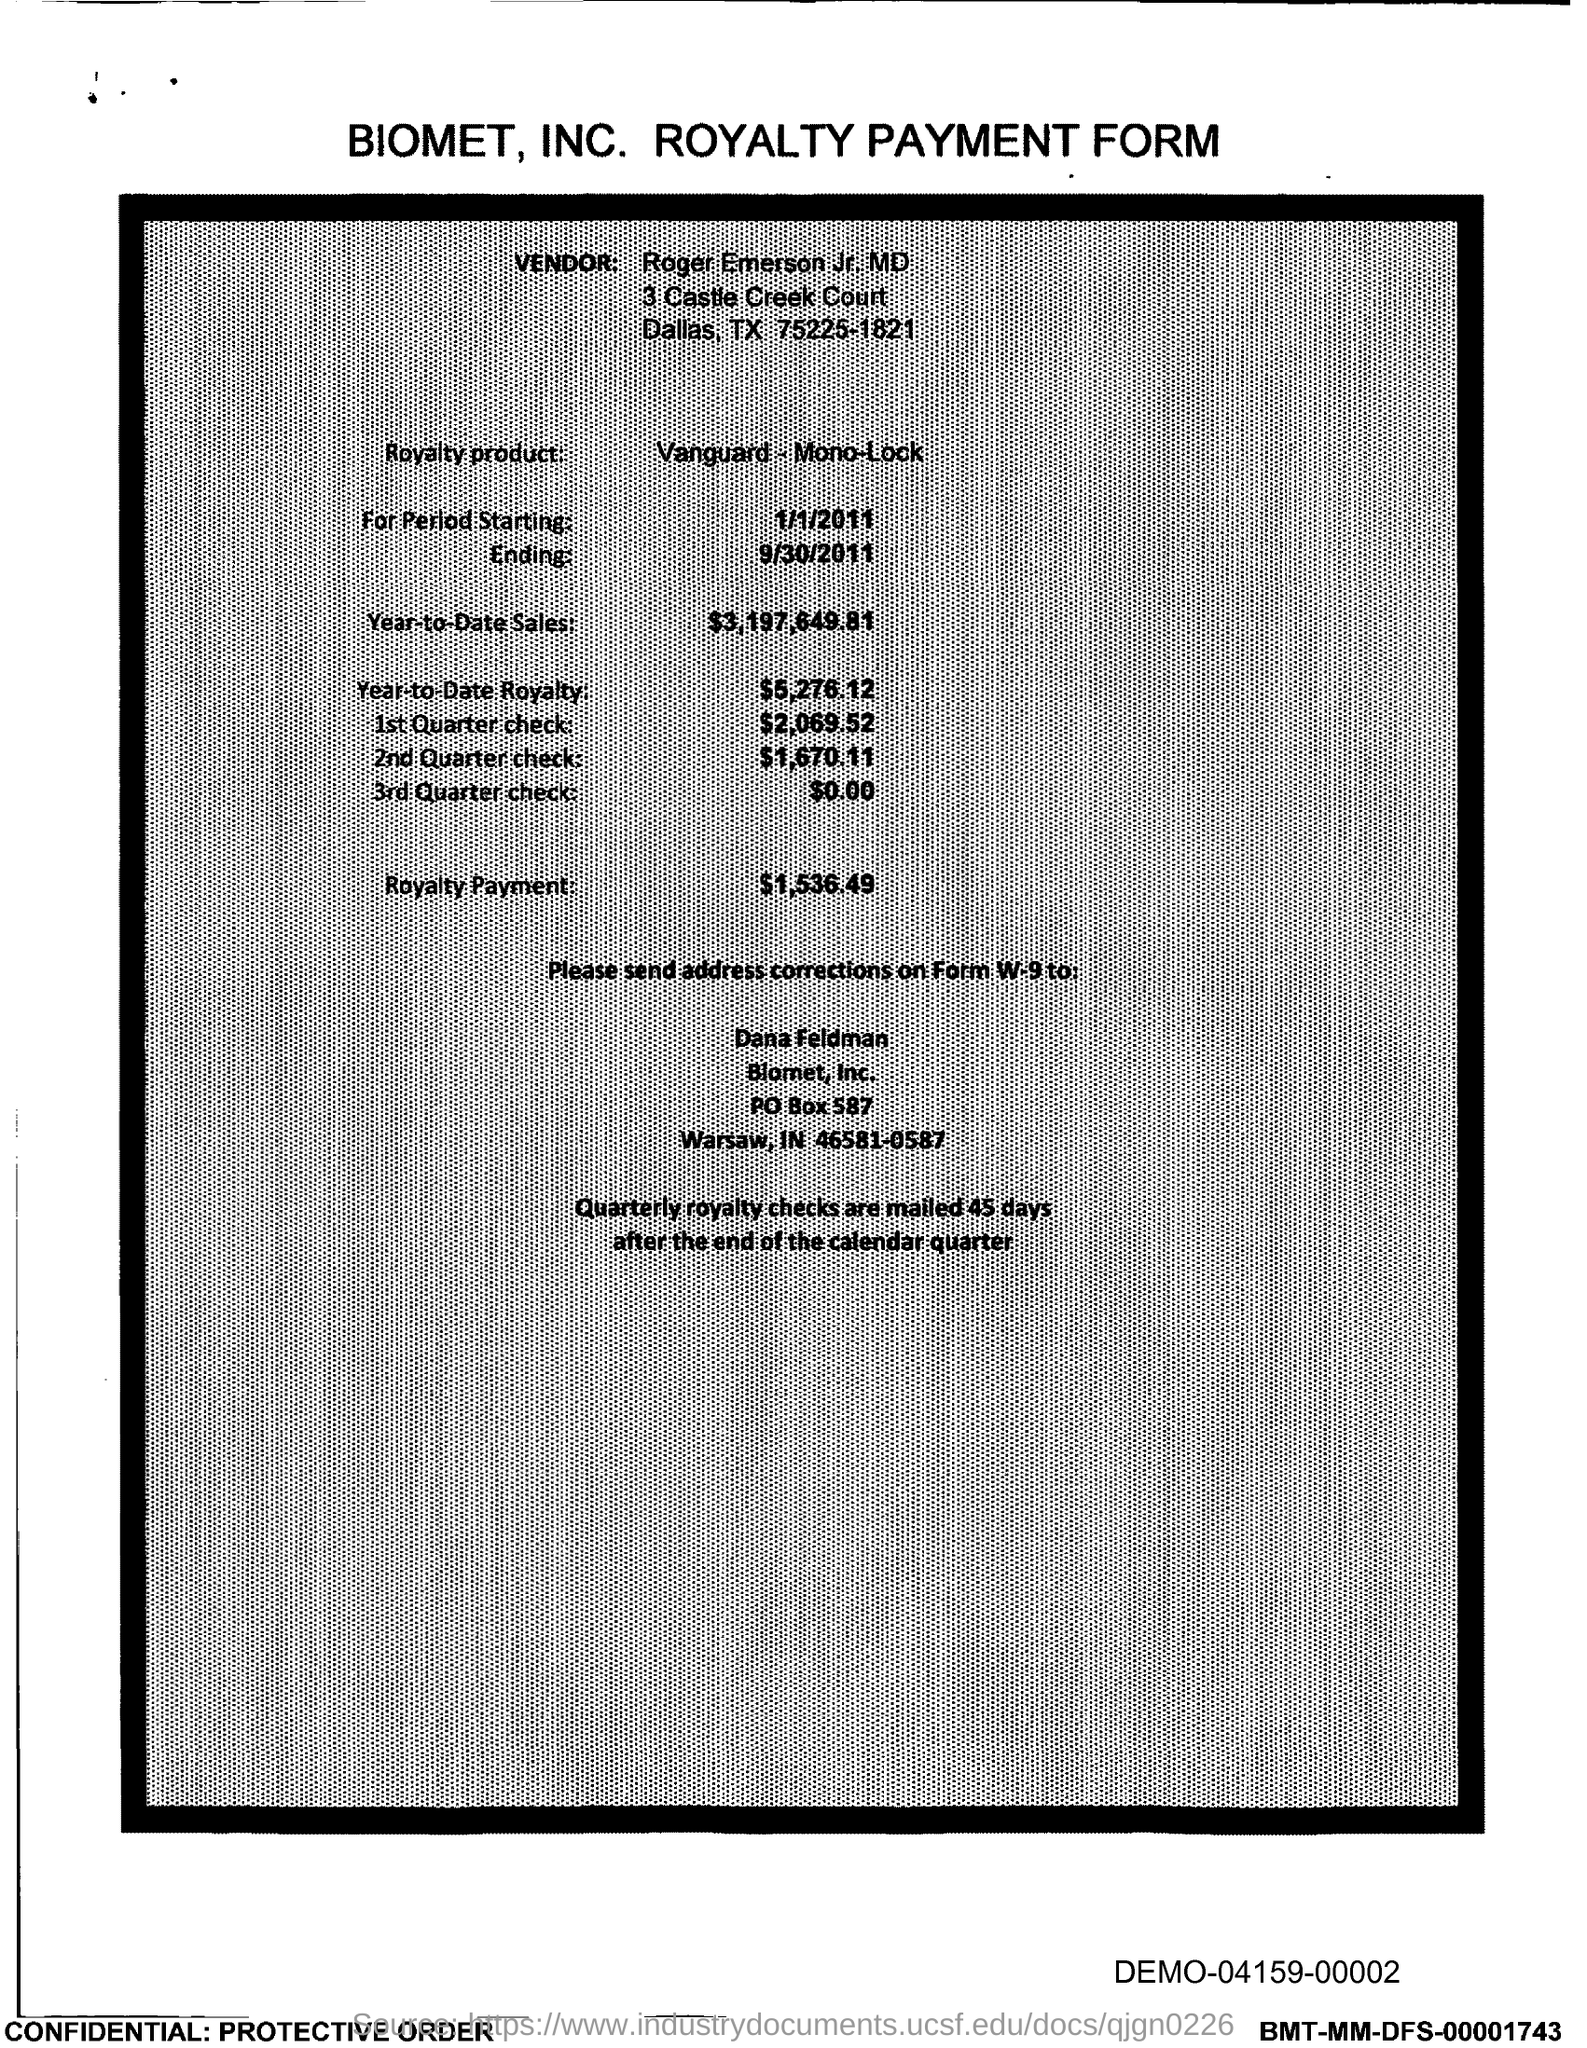Point out several critical features in this image. The PO Box number mentioned in the document is 587. 